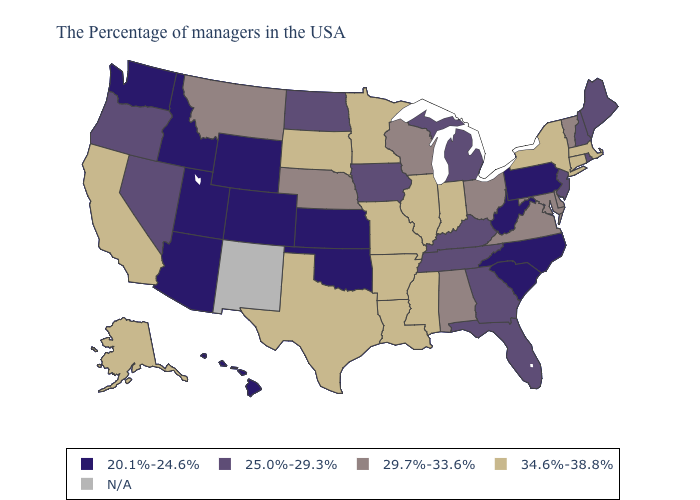Name the states that have a value in the range 29.7%-33.6%?
Give a very brief answer. Vermont, Delaware, Maryland, Virginia, Ohio, Alabama, Wisconsin, Nebraska, Montana. What is the value of Maryland?
Write a very short answer. 29.7%-33.6%. Which states hav the highest value in the South?
Be succinct. Mississippi, Louisiana, Arkansas, Texas. Does Tennessee have the lowest value in the South?
Concise answer only. No. What is the value of Virginia?
Concise answer only. 29.7%-33.6%. Name the states that have a value in the range N/A?
Give a very brief answer. New Mexico. What is the value of Kentucky?
Write a very short answer. 25.0%-29.3%. Name the states that have a value in the range 20.1%-24.6%?
Keep it brief. Pennsylvania, North Carolina, South Carolina, West Virginia, Kansas, Oklahoma, Wyoming, Colorado, Utah, Arizona, Idaho, Washington, Hawaii. What is the value of Michigan?
Be succinct. 25.0%-29.3%. What is the value of Georgia?
Concise answer only. 25.0%-29.3%. Which states have the lowest value in the South?
Answer briefly. North Carolina, South Carolina, West Virginia, Oklahoma. What is the value of Wisconsin?
Short answer required. 29.7%-33.6%. How many symbols are there in the legend?
Write a very short answer. 5. What is the value of California?
Keep it brief. 34.6%-38.8%. 